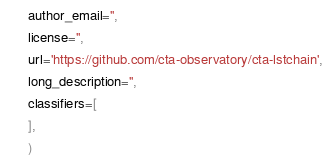Convert code to text. <code><loc_0><loc_0><loc_500><loc_500><_Python_>      author_email='',
      license='',
      url='https://github.com/cta-observatory/cta-lstchain',
      long_description='',
      classifiers=[
      ],
      )
</code> 